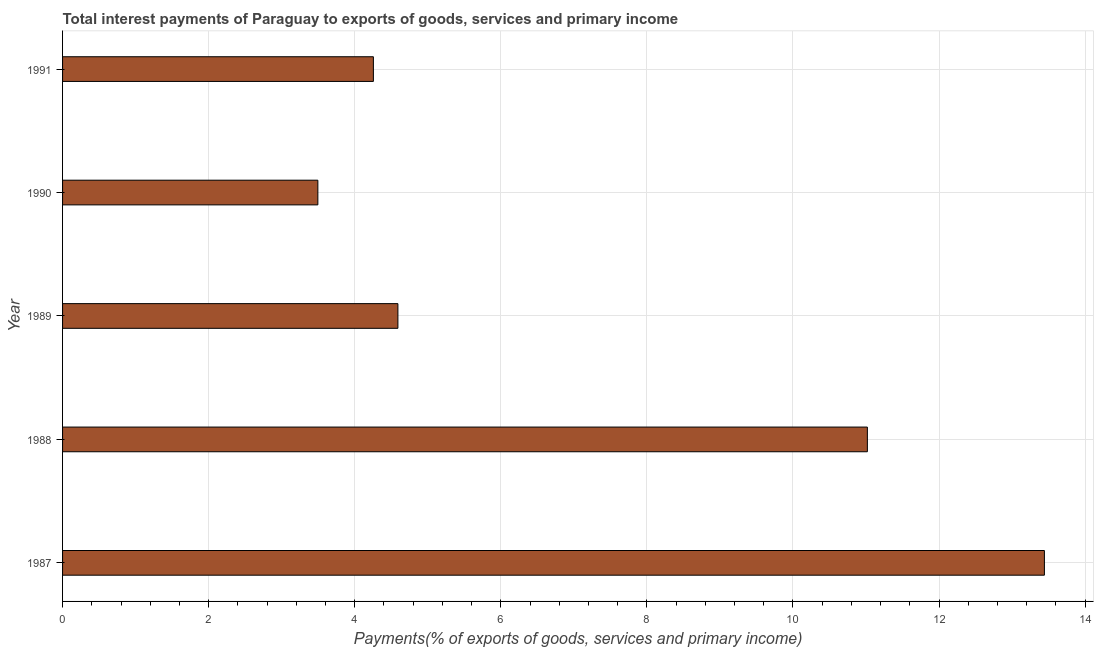Does the graph contain any zero values?
Offer a very short reply. No. Does the graph contain grids?
Make the answer very short. Yes. What is the title of the graph?
Give a very brief answer. Total interest payments of Paraguay to exports of goods, services and primary income. What is the label or title of the X-axis?
Ensure brevity in your answer.  Payments(% of exports of goods, services and primary income). What is the label or title of the Y-axis?
Your answer should be compact. Year. What is the total interest payments on external debt in 1988?
Your answer should be compact. 11.02. Across all years, what is the maximum total interest payments on external debt?
Provide a short and direct response. 13.44. Across all years, what is the minimum total interest payments on external debt?
Provide a succinct answer. 3.5. In which year was the total interest payments on external debt maximum?
Your answer should be very brief. 1987. In which year was the total interest payments on external debt minimum?
Provide a succinct answer. 1990. What is the sum of the total interest payments on external debt?
Your answer should be compact. 36.8. What is the difference between the total interest payments on external debt in 1988 and 1989?
Your response must be concise. 6.43. What is the average total interest payments on external debt per year?
Provide a succinct answer. 7.36. What is the median total interest payments on external debt?
Your answer should be compact. 4.59. Do a majority of the years between 1987 and 1989 (inclusive) have total interest payments on external debt greater than 8.8 %?
Provide a succinct answer. Yes. What is the ratio of the total interest payments on external debt in 1988 to that in 1989?
Offer a very short reply. 2.4. Is the difference between the total interest payments on external debt in 1987 and 1988 greater than the difference between any two years?
Your answer should be compact. No. What is the difference between the highest and the second highest total interest payments on external debt?
Ensure brevity in your answer.  2.42. What is the difference between the highest and the lowest total interest payments on external debt?
Give a very brief answer. 9.95. What is the difference between two consecutive major ticks on the X-axis?
Your answer should be compact. 2. What is the Payments(% of exports of goods, services and primary income) of 1987?
Make the answer very short. 13.44. What is the Payments(% of exports of goods, services and primary income) of 1988?
Your response must be concise. 11.02. What is the Payments(% of exports of goods, services and primary income) in 1989?
Your answer should be very brief. 4.59. What is the Payments(% of exports of goods, services and primary income) of 1990?
Give a very brief answer. 3.5. What is the Payments(% of exports of goods, services and primary income) in 1991?
Give a very brief answer. 4.26. What is the difference between the Payments(% of exports of goods, services and primary income) in 1987 and 1988?
Offer a terse response. 2.42. What is the difference between the Payments(% of exports of goods, services and primary income) in 1987 and 1989?
Your response must be concise. 8.85. What is the difference between the Payments(% of exports of goods, services and primary income) in 1987 and 1990?
Ensure brevity in your answer.  9.95. What is the difference between the Payments(% of exports of goods, services and primary income) in 1987 and 1991?
Keep it short and to the point. 9.19. What is the difference between the Payments(% of exports of goods, services and primary income) in 1988 and 1989?
Make the answer very short. 6.43. What is the difference between the Payments(% of exports of goods, services and primary income) in 1988 and 1990?
Offer a terse response. 7.52. What is the difference between the Payments(% of exports of goods, services and primary income) in 1988 and 1991?
Offer a very short reply. 6.76. What is the difference between the Payments(% of exports of goods, services and primary income) in 1989 and 1990?
Offer a terse response. 1.1. What is the difference between the Payments(% of exports of goods, services and primary income) in 1989 and 1991?
Offer a very short reply. 0.34. What is the difference between the Payments(% of exports of goods, services and primary income) in 1990 and 1991?
Your answer should be very brief. -0.76. What is the ratio of the Payments(% of exports of goods, services and primary income) in 1987 to that in 1988?
Ensure brevity in your answer.  1.22. What is the ratio of the Payments(% of exports of goods, services and primary income) in 1987 to that in 1989?
Offer a terse response. 2.93. What is the ratio of the Payments(% of exports of goods, services and primary income) in 1987 to that in 1990?
Give a very brief answer. 3.85. What is the ratio of the Payments(% of exports of goods, services and primary income) in 1987 to that in 1991?
Provide a succinct answer. 3.16. What is the ratio of the Payments(% of exports of goods, services and primary income) in 1988 to that in 1990?
Offer a terse response. 3.15. What is the ratio of the Payments(% of exports of goods, services and primary income) in 1988 to that in 1991?
Ensure brevity in your answer.  2.59. What is the ratio of the Payments(% of exports of goods, services and primary income) in 1989 to that in 1990?
Your answer should be very brief. 1.31. What is the ratio of the Payments(% of exports of goods, services and primary income) in 1989 to that in 1991?
Keep it short and to the point. 1.08. What is the ratio of the Payments(% of exports of goods, services and primary income) in 1990 to that in 1991?
Your response must be concise. 0.82. 